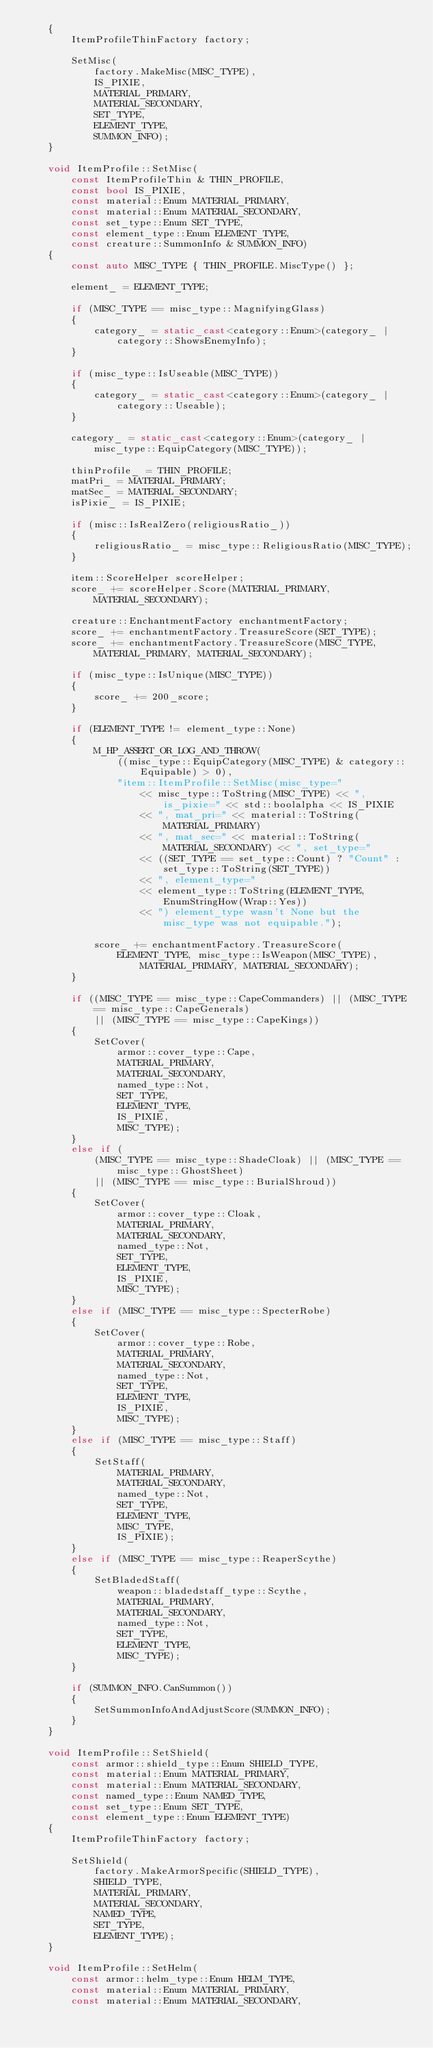Convert code to text. <code><loc_0><loc_0><loc_500><loc_500><_C++_>    {
        ItemProfileThinFactory factory;

        SetMisc(
            factory.MakeMisc(MISC_TYPE),
            IS_PIXIE,
            MATERIAL_PRIMARY,
            MATERIAL_SECONDARY,
            SET_TYPE,
            ELEMENT_TYPE,
            SUMMON_INFO);
    }

    void ItemProfile::SetMisc(
        const ItemProfileThin & THIN_PROFILE,
        const bool IS_PIXIE,
        const material::Enum MATERIAL_PRIMARY,
        const material::Enum MATERIAL_SECONDARY,
        const set_type::Enum SET_TYPE,
        const element_type::Enum ELEMENT_TYPE,
        const creature::SummonInfo & SUMMON_INFO)
    {
        const auto MISC_TYPE { THIN_PROFILE.MiscType() };

        element_ = ELEMENT_TYPE;

        if (MISC_TYPE == misc_type::MagnifyingGlass)
        {
            category_ = static_cast<category::Enum>(category_ | category::ShowsEnemyInfo);
        }

        if (misc_type::IsUseable(MISC_TYPE))
        {
            category_ = static_cast<category::Enum>(category_ | category::Useable);
        }

        category_ = static_cast<category::Enum>(category_ | misc_type::EquipCategory(MISC_TYPE));

        thinProfile_ = THIN_PROFILE;
        matPri_ = MATERIAL_PRIMARY;
        matSec_ = MATERIAL_SECONDARY;
        isPixie_ = IS_PIXIE;

        if (misc::IsRealZero(religiousRatio_))
        {
            religiousRatio_ = misc_type::ReligiousRatio(MISC_TYPE);
        }

        item::ScoreHelper scoreHelper;
        score_ += scoreHelper.Score(MATERIAL_PRIMARY, MATERIAL_SECONDARY);

        creature::EnchantmentFactory enchantmentFactory;
        score_ += enchantmentFactory.TreasureScore(SET_TYPE);
        score_ += enchantmentFactory.TreasureScore(MISC_TYPE, MATERIAL_PRIMARY, MATERIAL_SECONDARY);

        if (misc_type::IsUnique(MISC_TYPE))
        {
            score_ += 200_score;
        }

        if (ELEMENT_TYPE != element_type::None)
        {
            M_HP_ASSERT_OR_LOG_AND_THROW(
                ((misc_type::EquipCategory(MISC_TYPE) & category::Equipable) > 0),
                "item::ItemProfile::SetMisc(misc_type="
                    << misc_type::ToString(MISC_TYPE) << ", is_pixie=" << std::boolalpha << IS_PIXIE
                    << ", mat_pri=" << material::ToString(MATERIAL_PRIMARY)
                    << ", mat_sec=" << material::ToString(MATERIAL_SECONDARY) << ", set_type="
                    << ((SET_TYPE == set_type::Count) ? "Count" : set_type::ToString(SET_TYPE))
                    << ", element_type="
                    << element_type::ToString(ELEMENT_TYPE, EnumStringHow(Wrap::Yes))
                    << ") element_type wasn't None but the misc_type was not equipable.");

            score_ += enchantmentFactory.TreasureScore(
                ELEMENT_TYPE, misc_type::IsWeapon(MISC_TYPE), MATERIAL_PRIMARY, MATERIAL_SECONDARY);
        }

        if ((MISC_TYPE == misc_type::CapeCommanders) || (MISC_TYPE == misc_type::CapeGenerals)
            || (MISC_TYPE == misc_type::CapeKings))
        {
            SetCover(
                armor::cover_type::Cape,
                MATERIAL_PRIMARY,
                MATERIAL_SECONDARY,
                named_type::Not,
                SET_TYPE,
                ELEMENT_TYPE,
                IS_PIXIE,
                MISC_TYPE);
        }
        else if (
            (MISC_TYPE == misc_type::ShadeCloak) || (MISC_TYPE == misc_type::GhostSheet)
            || (MISC_TYPE == misc_type::BurialShroud))
        {
            SetCover(
                armor::cover_type::Cloak,
                MATERIAL_PRIMARY,
                MATERIAL_SECONDARY,
                named_type::Not,
                SET_TYPE,
                ELEMENT_TYPE,
                IS_PIXIE,
                MISC_TYPE);
        }
        else if (MISC_TYPE == misc_type::SpecterRobe)
        {
            SetCover(
                armor::cover_type::Robe,
                MATERIAL_PRIMARY,
                MATERIAL_SECONDARY,
                named_type::Not,
                SET_TYPE,
                ELEMENT_TYPE,
                IS_PIXIE,
                MISC_TYPE);
        }
        else if (MISC_TYPE == misc_type::Staff)
        {
            SetStaff(
                MATERIAL_PRIMARY,
                MATERIAL_SECONDARY,
                named_type::Not,
                SET_TYPE,
                ELEMENT_TYPE,
                MISC_TYPE,
                IS_PIXIE);
        }
        else if (MISC_TYPE == misc_type::ReaperScythe)
        {
            SetBladedStaff(
                weapon::bladedstaff_type::Scythe,
                MATERIAL_PRIMARY,
                MATERIAL_SECONDARY,
                named_type::Not,
                SET_TYPE,
                ELEMENT_TYPE,
                MISC_TYPE);
        }

        if (SUMMON_INFO.CanSummon())
        {
            SetSummonInfoAndAdjustScore(SUMMON_INFO);
        }
    }

    void ItemProfile::SetShield(
        const armor::shield_type::Enum SHIELD_TYPE,
        const material::Enum MATERIAL_PRIMARY,
        const material::Enum MATERIAL_SECONDARY,
        const named_type::Enum NAMED_TYPE,
        const set_type::Enum SET_TYPE,
        const element_type::Enum ELEMENT_TYPE)
    {
        ItemProfileThinFactory factory;

        SetShield(
            factory.MakeArmorSpecific(SHIELD_TYPE),
            SHIELD_TYPE,
            MATERIAL_PRIMARY,
            MATERIAL_SECONDARY,
            NAMED_TYPE,
            SET_TYPE,
            ELEMENT_TYPE);
    }

    void ItemProfile::SetHelm(
        const armor::helm_type::Enum HELM_TYPE,
        const material::Enum MATERIAL_PRIMARY,
        const material::Enum MATERIAL_SECONDARY,</code> 